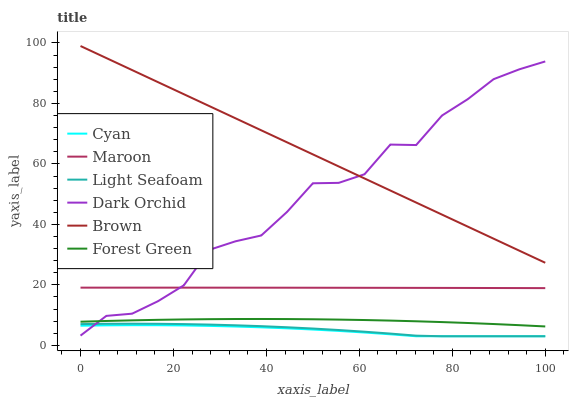Does Cyan have the minimum area under the curve?
Answer yes or no. Yes. Does Brown have the maximum area under the curve?
Answer yes or no. Yes. Does Dark Orchid have the minimum area under the curve?
Answer yes or no. No. Does Dark Orchid have the maximum area under the curve?
Answer yes or no. No. Is Brown the smoothest?
Answer yes or no. Yes. Is Dark Orchid the roughest?
Answer yes or no. Yes. Is Forest Green the smoothest?
Answer yes or no. No. Is Forest Green the roughest?
Answer yes or no. No. Does Cyan have the lowest value?
Answer yes or no. Yes. Does Dark Orchid have the lowest value?
Answer yes or no. No. Does Brown have the highest value?
Answer yes or no. Yes. Does Dark Orchid have the highest value?
Answer yes or no. No. Is Light Seafoam less than Brown?
Answer yes or no. Yes. Is Maroon greater than Cyan?
Answer yes or no. Yes. Does Light Seafoam intersect Dark Orchid?
Answer yes or no. Yes. Is Light Seafoam less than Dark Orchid?
Answer yes or no. No. Is Light Seafoam greater than Dark Orchid?
Answer yes or no. No. Does Light Seafoam intersect Brown?
Answer yes or no. No. 